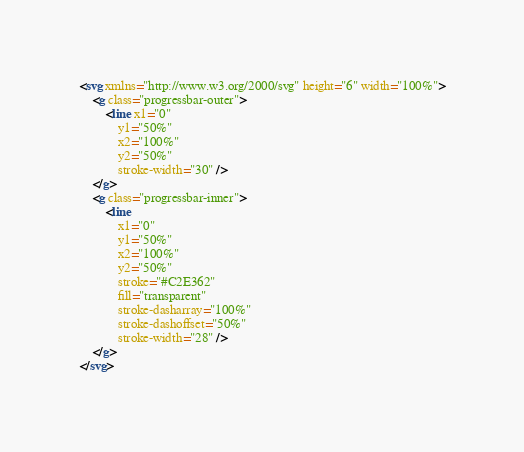Convert code to text. <code><loc_0><loc_0><loc_500><loc_500><_HTML_><svg xmlns="http://www.w3.org/2000/svg" height="6" width="100%">
    <g class="progressbar-outer">
        <line x1="0"
            y1="50%"
            x2="100%"
            y2="50%"
            stroke-width="30" />
    </g>
    <g class="progressbar-inner">
        <line
            x1="0"
            y1="50%"
            x2="100%"
            y2="50%"
            stroke="#C2E362" 
            fill="transparent" 
            stroke-dasharray="100%" 
            stroke-dashoffset="50%" 
            stroke-width="28" />
    </g>
</svg>
</code> 